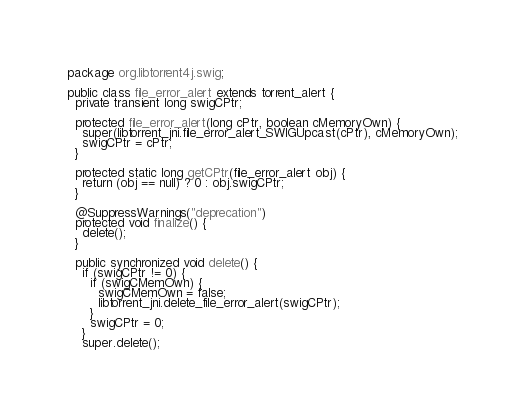Convert code to text. <code><loc_0><loc_0><loc_500><loc_500><_Java_>package org.libtorrent4j.swig;

public class file_error_alert extends torrent_alert {
  private transient long swigCPtr;

  protected file_error_alert(long cPtr, boolean cMemoryOwn) {
    super(libtorrent_jni.file_error_alert_SWIGUpcast(cPtr), cMemoryOwn);
    swigCPtr = cPtr;
  }

  protected static long getCPtr(file_error_alert obj) {
    return (obj == null) ? 0 : obj.swigCPtr;
  }

  @SuppressWarnings("deprecation")
  protected void finalize() {
    delete();
  }

  public synchronized void delete() {
    if (swigCPtr != 0) {
      if (swigCMemOwn) {
        swigCMemOwn = false;
        libtorrent_jni.delete_file_error_alert(swigCPtr);
      }
      swigCPtr = 0;
    }
    super.delete();</code> 